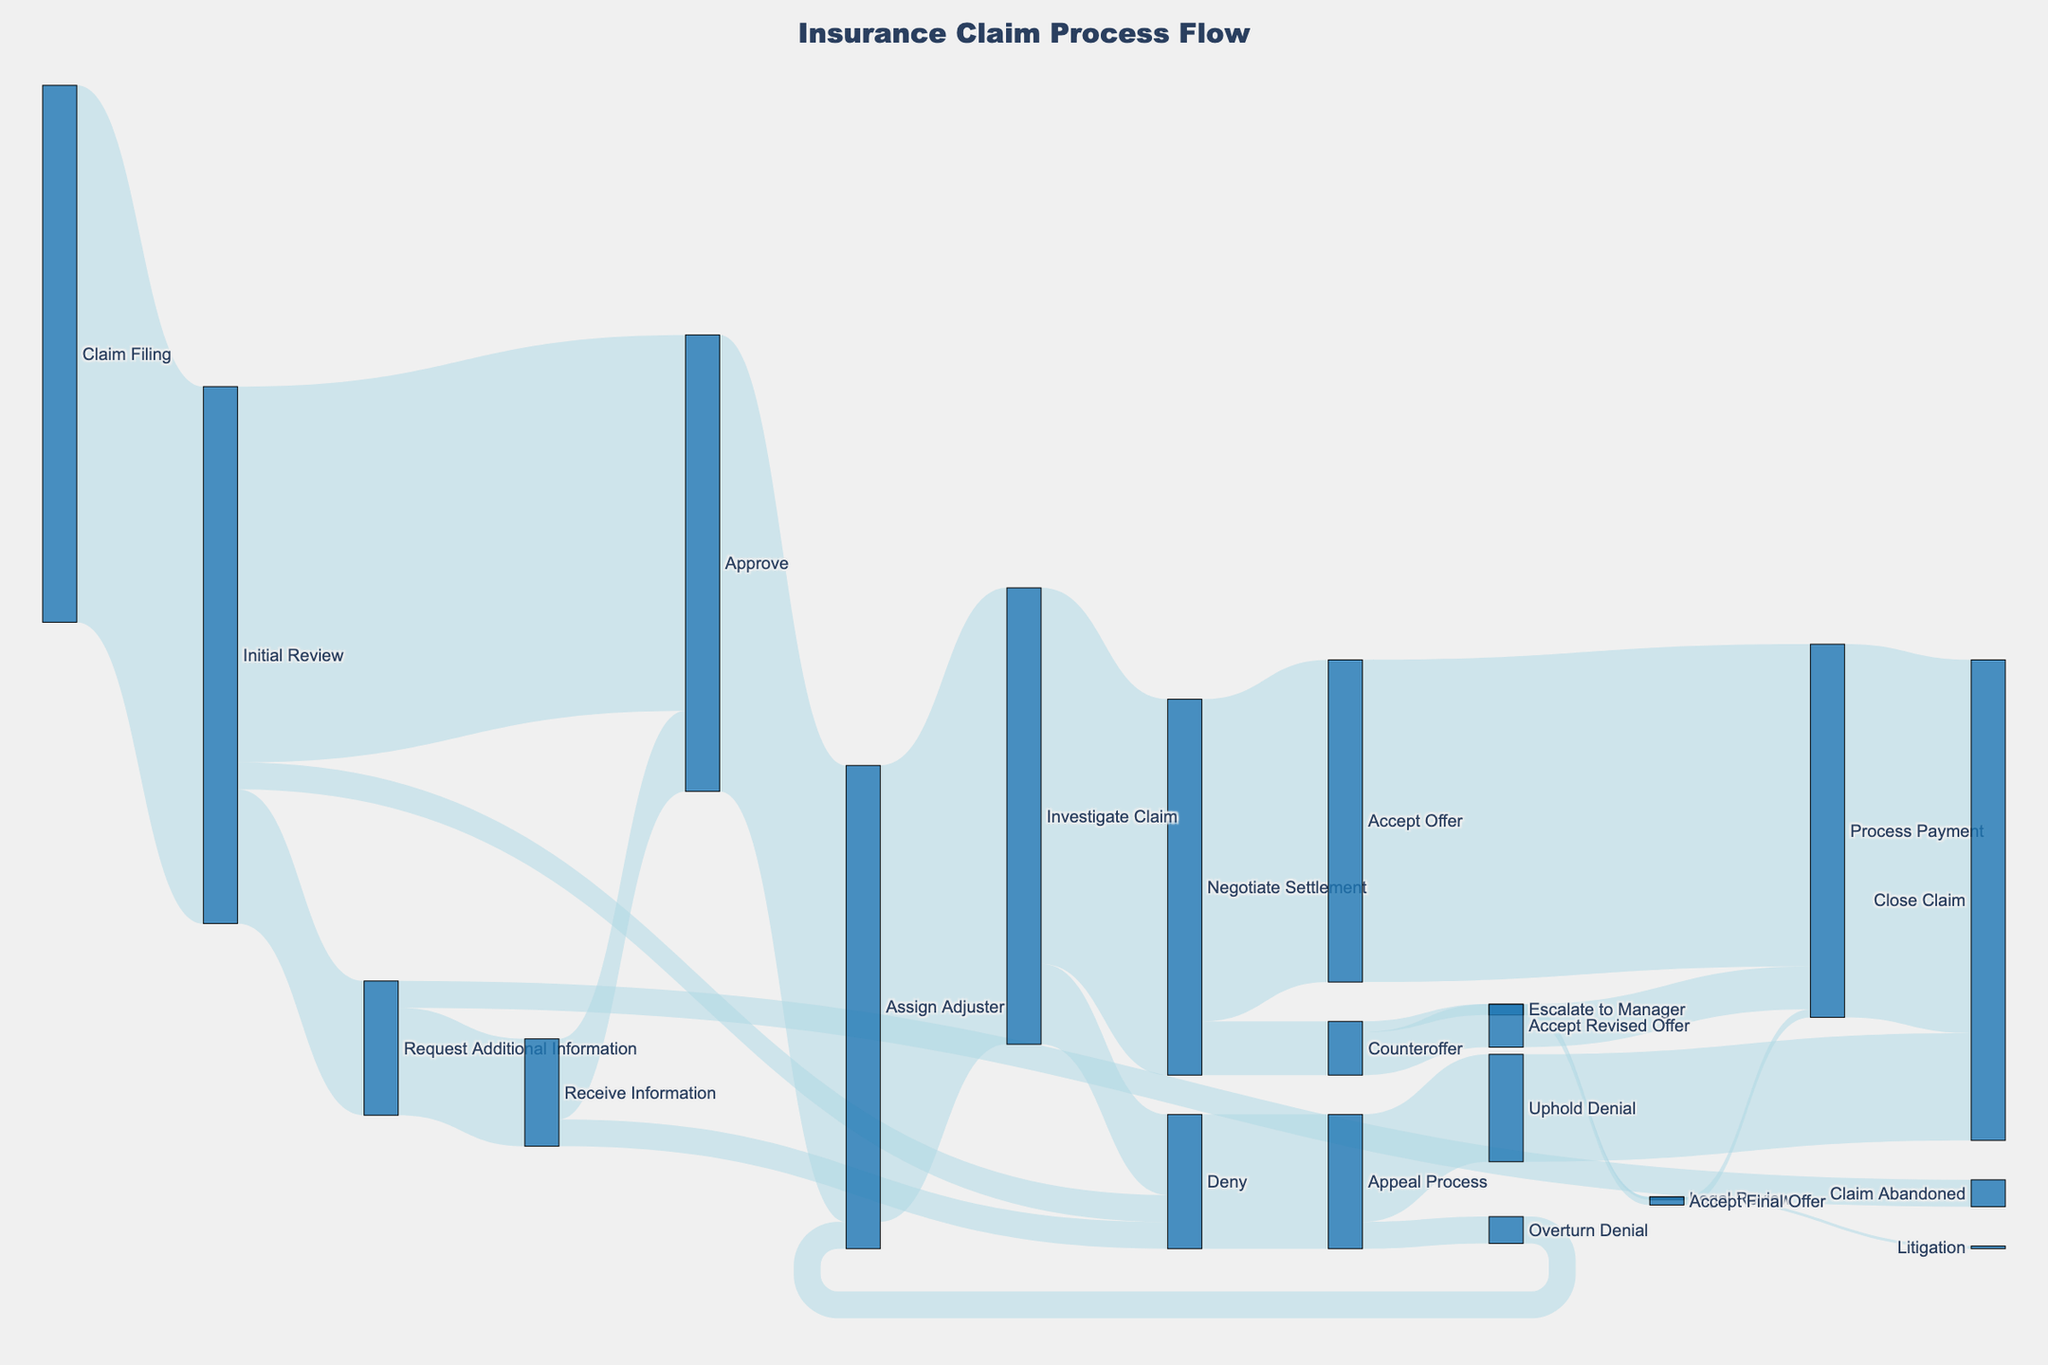Which step has the most claims transitioning out from "Initial Review"? Look at the transitions out of "Initial Review" and compare their values: Approve (700), Request Additional Information (250), Deny (50). Approve has the most with 700.
Answer: Approve How many claims end up in the "Close Claim" category? Add values leading to "Close Claim": Process Payment (695) + Uphold Denial (200). The total is 895.
Answer: 895 What's the difference in the number of claims between "Negotiate Settlement" and "Counteroffer"? Compare the values for "Negotiate Settlement" (700) and "Counteroffer" (100). The difference is 700 - 100 = 600.
Answer: 600 Which transition has fewer claims: from “Investigate Claim” to “Deny” or “Negotiate Settlement” to “Counteroffer”? Look at both paths: Investigate Claim -> Deny (150) and Negotiate Settlement -> Counteroffer (100). The latter has fewer claims with 100.
Answer: Negotiate Settlement to Counteroffer What is the total number of claims that were approved after requesting additional information? Add values for transitions related to approvals after requesting information: Receive Information -> Approve (150). This gives us 150.
Answer: 150 Which transition carries more claims: “Initial Review” to “Request Additional Information” or “Appeal Process” to “Uphold Denial”? Compare the values of each path: Initial Review -> Request Additional Information (250) and Appeal Process -> Uphold Denial (200). The former has more with 250 claims.
Answer: Initial Review to Request Additional Information How many claims moved from “Counteroffer” to “Escalate to Manager”? Look at the value for the transition: Counteroffer -> Escalate to Manager, which is 20 claims.
Answer: 20 In the final step of "Process Payment," how many claims were processed following an acceptance of a different type? Add values leading to "Process Payment": Accept Offer (600), Accept Revised Offer (80), Accept Final Offer (15). Total is 600 + 80 + 15 = 695.
Answer: 695 What are the total cases that escalated to the manager but did not end in litigation? Break it down: Escalate to Manager -> Accept Final Offer (15) or Legal Review (5). Only Legal Review leads to litigation, so 15 claims did not end in litigation.
Answer: 15 From the "Appeal Process," how many claims reverted to be assigned to an adjuster again? Check the value: Appeal Process -> Overturn Denial (50), leading to Assign Adjuster.
Answer: 50 